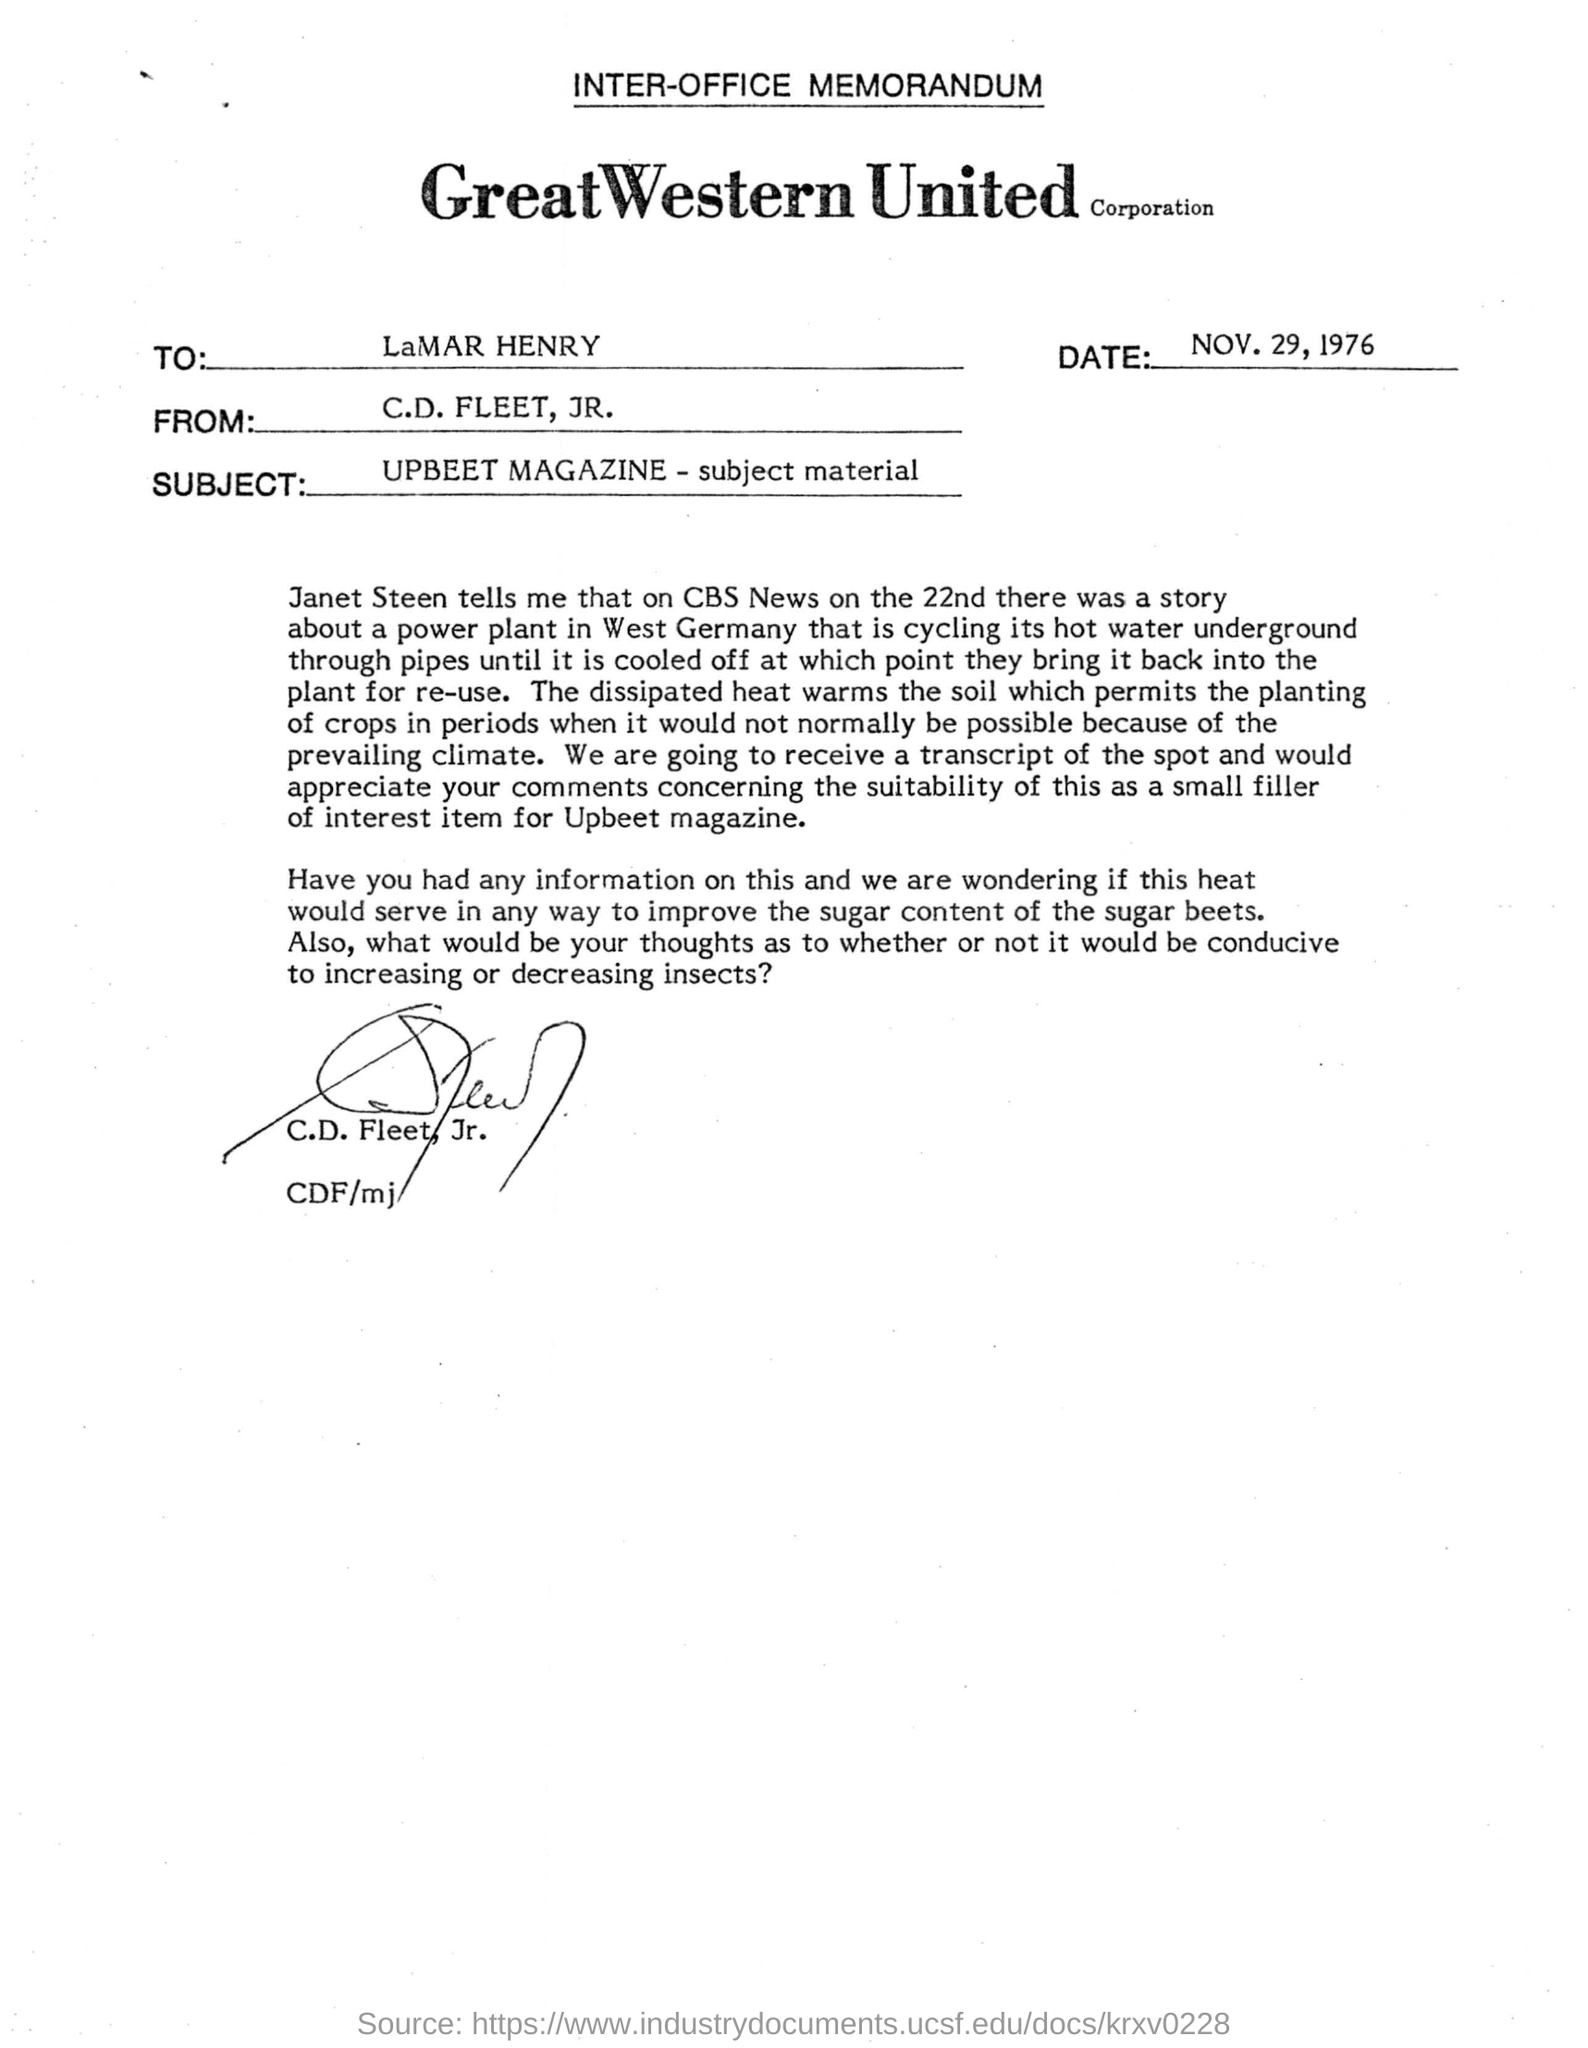Highlight a few significant elements in this photo. The subject of this memorandum is UPBEET MAGAZINE, and its subject matter. The memorandum was signed by C.D. Fleet, Jr. This letter is extracted from UPBEET MAGAZINE. The letter is addressed to LaMAR HENRY. 